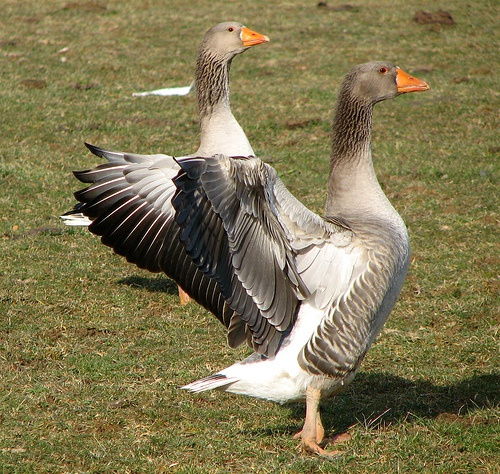Describe the objects in this image and their specific colors. I can see a bird in tan, black, ivory, gray, and darkgray tones in this image. 